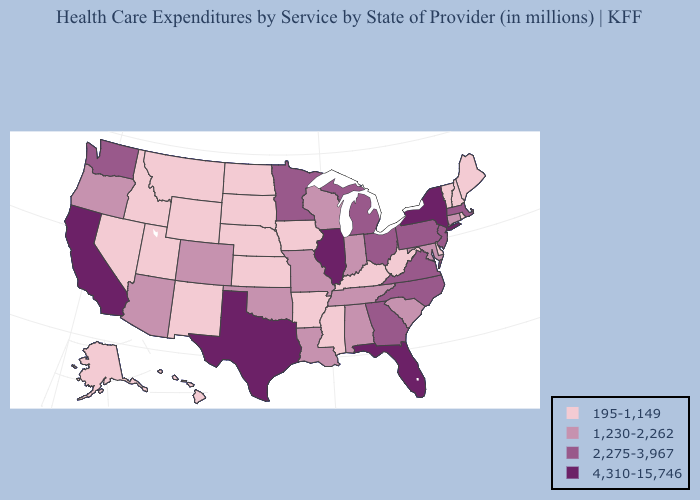What is the lowest value in the USA?
Keep it brief. 195-1,149. Name the states that have a value in the range 4,310-15,746?
Quick response, please. California, Florida, Illinois, New York, Texas. Which states have the highest value in the USA?
Give a very brief answer. California, Florida, Illinois, New York, Texas. Among the states that border Wisconsin , does Minnesota have the lowest value?
Give a very brief answer. No. What is the highest value in the MidWest ?
Keep it brief. 4,310-15,746. Name the states that have a value in the range 1,230-2,262?
Write a very short answer. Alabama, Arizona, Colorado, Connecticut, Indiana, Louisiana, Maryland, Missouri, Oklahoma, Oregon, South Carolina, Tennessee, Wisconsin. Does Texas have the same value as Minnesota?
Quick response, please. No. Which states have the lowest value in the USA?
Concise answer only. Alaska, Arkansas, Delaware, Hawaii, Idaho, Iowa, Kansas, Kentucky, Maine, Mississippi, Montana, Nebraska, Nevada, New Hampshire, New Mexico, North Dakota, Rhode Island, South Dakota, Utah, Vermont, West Virginia, Wyoming. What is the lowest value in states that border Iowa?
Concise answer only. 195-1,149. Is the legend a continuous bar?
Keep it brief. No. What is the value of Missouri?
Concise answer only. 1,230-2,262. Name the states that have a value in the range 2,275-3,967?
Give a very brief answer. Georgia, Massachusetts, Michigan, Minnesota, New Jersey, North Carolina, Ohio, Pennsylvania, Virginia, Washington. Among the states that border Iowa , does Illinois have the highest value?
Short answer required. Yes. How many symbols are there in the legend?
Concise answer only. 4. Among the states that border Montana , which have the lowest value?
Answer briefly. Idaho, North Dakota, South Dakota, Wyoming. 